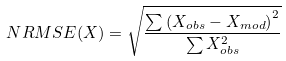Convert formula to latex. <formula><loc_0><loc_0><loc_500><loc_500>N R M S E ( X ) = \sqrt { \frac { \sum \left ( X _ { o b s } - X _ { m o d } \right ) ^ { 2 } } { \sum X _ { o b s } ^ { 2 } } }</formula> 